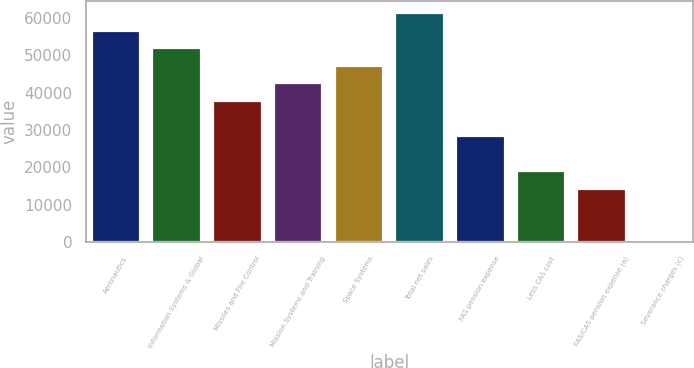Convert chart. <chart><loc_0><loc_0><loc_500><loc_500><bar_chart><fcel>Aeronautics<fcel>Information Systems & Global<fcel>Missiles and Fire Control<fcel>Mission Systems and Training<fcel>Space Systems<fcel>Total net sales<fcel>FAS pension expense<fcel>Less CAS cost<fcel>FAS/CAS pension expense (a)<fcel>Severance charges (c)<nl><fcel>56608.8<fcel>51895.4<fcel>37755.2<fcel>42468.6<fcel>47182<fcel>61322.2<fcel>28328.4<fcel>18901.6<fcel>14188.2<fcel>48<nl></chart> 